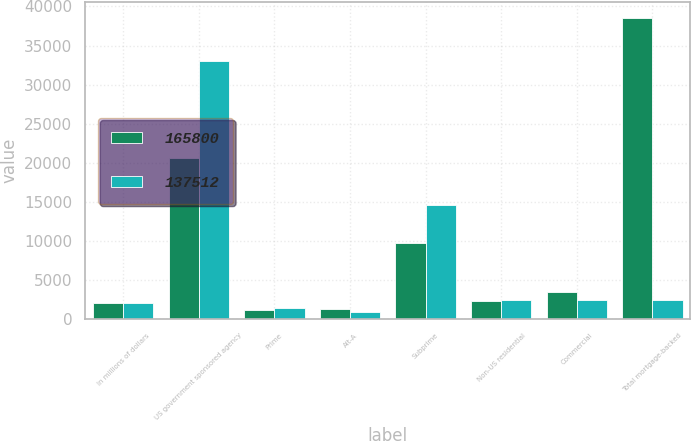<chart> <loc_0><loc_0><loc_500><loc_500><stacked_bar_chart><ecel><fcel>In millions of dollars<fcel>US government sponsored agency<fcel>Prime<fcel>Alt-A<fcel>Subprime<fcel>Non-US residential<fcel>Commercial<fcel>Total mortgage-backed<nl><fcel>165800<fcel>2009<fcel>20638<fcel>1156<fcel>1229<fcel>9734<fcel>2368<fcel>3455<fcel>38580<nl><fcel>137512<fcel>2008<fcel>32981<fcel>1416<fcel>913<fcel>14552<fcel>2447<fcel>2501<fcel>2447<nl></chart> 